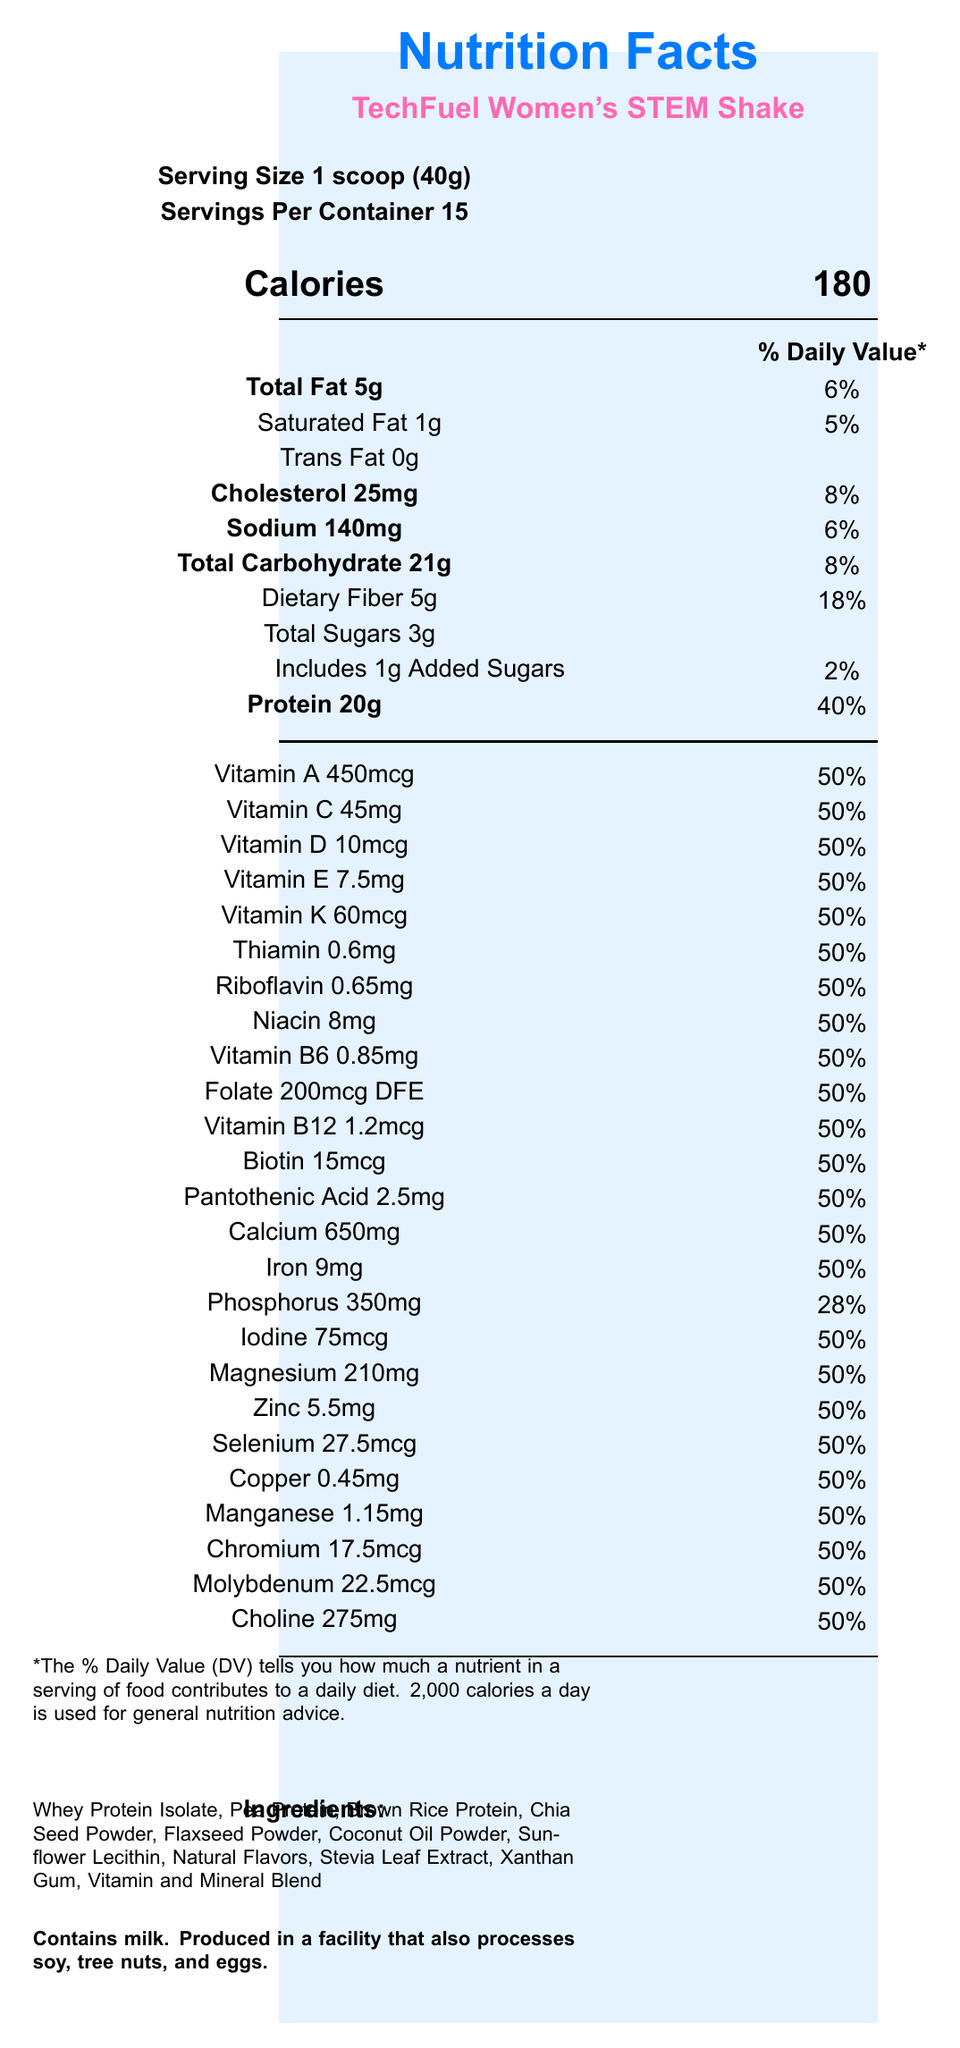what is the serving size? The document states the serving size as "1 scoop (40g)".
Answer: 1 scoop (40g) how many servings are there per container? The document mentions that there are 15 servings per container.
Answer: 15 how much protein is in each serving? The document specifies that each serving contains 20g of protein.
Answer: 20g how many calories does one serving contain? The document states that there are 180 calories per serving.
Answer: 180 how much added sugar is in each serving? The document indicates that each serving includes 1g of added sugars.
Answer: 1g what is the daily value percentage of dietary fiber? The daily value percentage for dietary fiber is listed as 18% in the document.
Answer: 18% how many grams of total fat does each serving contain? The document lists 5g of total fat per serving.
Answer: 5g what is the daily value percentage for vitamin D? The document shows that each serving contains 50% of the daily value for vitamin D.
Answer: 50% what percentage of the daily value for iron does one serving provide? A. 28% B. 40% C. 50% D. 18% The document indicates that one serving provides 50% of the daily value for iron.
Answer: C. 50% which ingredient might be an allergen? A. Whey Protein Isolate B. Pea Protein C. Natural Flavors The allergen information section lists milk, which is present in Whey Protein Isolate as an allergen.
Answer: A. Whey Protein Isolate does this product contain any trans fat? The document states that the trans fat content is 0g.
Answer: No does the product contain any artificial sweeteners? The ingredients list includes Stevia Leaf Extract, which is a natural sweetener, and does not mention any artificial sweeteners.
Answer: No summarize the main nutritional benefits of the TechFuel Women's STEM Shake. The document highlights both macronutrient and micronutrient content, emphasizing protein, essential vitamins, and minerals. It also mentions special features that support mental and cognitive health, suitable for women in STEM fields.
Answer: The TechFuel Women's STEM Shake provides a well-balanced mix of macronutrients including 20g of protein, 5g of total fat, and 21g of carbohydrates per serving. It is rich in essential vitamins and minerals like vitamin A, C, D, E, and K, each making up 50% of the daily value, and includes crucial B-vitamins and minerals tailored to support cognitive function, mental clarity, energy metabolism, and brain health. what are the ingredients listed? The document enumerates all the ingredients clearly.
Answer: Whey Protein Isolate, Pea Protein, Brown Rice Protein, Chia Seed Powder, Flaxseed Powder, Coconut Oil Powder, Sunflower Lecithin, Natural Flavors, Stevia Leaf Extract, Xanthan Gum, Vitamin and Mineral Blend what is the address of the manufacturer? This information is listed under the manufacturer's information section.
Answer: 123 Science Park Drive, Silicon Valley, CA 94025 what is the recommended mixing ratio for a serving? The document provides this information in the directions section.
Answer: Mix 1 scoop (40g) with 8-10 oz of cold water or your favorite beverage. how many types of protein are in the ingredient list? The document lists these three sources of protein in the ingredients section.
Answer: Three types: Whey Protein Isolate, Pea Protein, Brown Rice Protein what is not included in the listed features? A. Supports cognitive function B. Enhances muscle growth C. Contains omega-3 fatty acids D. Combats oxidative stress The document does not list enhancing muscle growth as a feature, while the others are mentioned.
Answer: B. Enhances muscle growth is this product suitable for individuals with a soy allergy? The document states that the product is produced in a facility that also processes soy, which poses a risk for individuals with soy allergies.
Answer: No how much calcium is in each serving? The document specifies that each serving contains 650mg of calcium.
Answer: 650mg what is the special feature related to mental function? The document lists this feature in the special features section.
Answer: Formulated to support cognitive function and mental clarity which vitamin has the highest milligram content per serving? The document lists the amount of each vitamin per serving, and Vitamin C has the highest milligram content at 45mg.
Answer: Vitamin C, 45mg what is the daily value percentage for vitamin B12? The document states that each serving contains 50% of the daily value for vitamin B12.
Answer: 50% where should this product be stored after opening? The document advises refrigerating the product after opening for best freshness.
Answer: Refrigerated for best freshness does the product contain caffeine? The document does not mention the presence of caffeine in the ingredients or special features.
Answer: Not enough information 